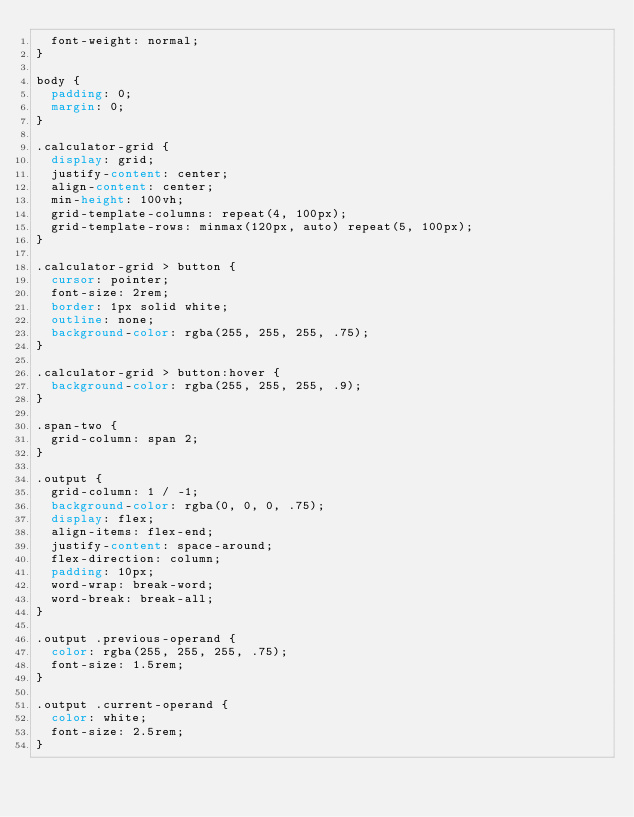<code> <loc_0><loc_0><loc_500><loc_500><_CSS_>  font-weight: normal;
}

body {
  padding: 0;
  margin: 0;
}

.calculator-grid {
  display: grid;
  justify-content: center;
  align-content: center;
  min-height: 100vh;
  grid-template-columns: repeat(4, 100px);
  grid-template-rows: minmax(120px, auto) repeat(5, 100px);
}

.calculator-grid > button {
  cursor: pointer;
  font-size: 2rem;
  border: 1px solid white;
  outline: none;
  background-color: rgba(255, 255, 255, .75);
}

.calculator-grid > button:hover {
  background-color: rgba(255, 255, 255, .9);
}

.span-two {
  grid-column: span 2;
}

.output {
  grid-column: 1 / -1;
  background-color: rgba(0, 0, 0, .75);
  display: flex;
  align-items: flex-end;
  justify-content: space-around;
  flex-direction: column;
  padding: 10px;
  word-wrap: break-word;
  word-break: break-all;
}

.output .previous-operand {
  color: rgba(255, 255, 255, .75);
  font-size: 1.5rem;
}

.output .current-operand {
  color: white;
  font-size: 2.5rem;
}</code> 